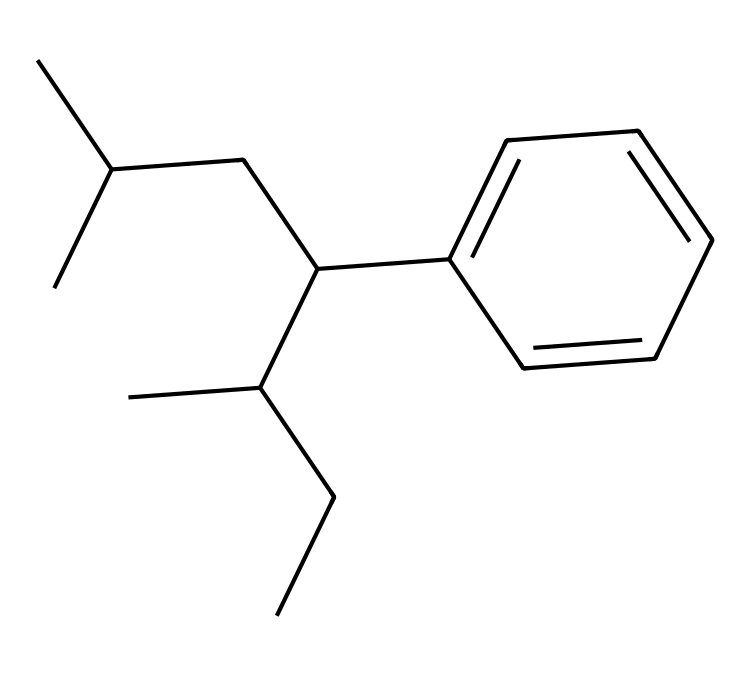What is the primary constituent of this chemical? This chemical has the structure that indicates it's primarily composed of carbon and hydrogen atoms, characteristic of hydrocarbons.
Answer: hydrocarbon How many carbon atoms are in this structure? Counting the carbon symbols in the SMILES representation indicates there are 15 carbon atoms.
Answer: 15 What functional group is present in this molecule? The structure does not exhibit a specific functional group like hydroxyl or carboxyl, categorizing it as a non-functional hydrocarbon rather than a compound with functional groups.
Answer: none What type of polymer is represented by this structure? The arrangement with long chains of carbon suggests it is a thermoplastic polymer, commonly known as polystyrene, used in food containers.
Answer: thermoplastic What is a typical application of this polymer? Given that this is polystyrene, its main application is in the production of disposable food containers and packaging.
Answer: food containers How does the structure affect the material's properties? The linear and branched hydrocarbon chains in polystyrene contribute to its rigidity and strength, making it suitable for structural applications like containers.
Answer: rigidity What is the most noticeable physical property of this chemical? The molecular structure suggests that it is solid at room temperature, which is a common characteristic of polystyrene.
Answer: solid 